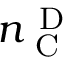<formula> <loc_0><loc_0><loc_500><loc_500>n _ { C } ^ { D }</formula> 